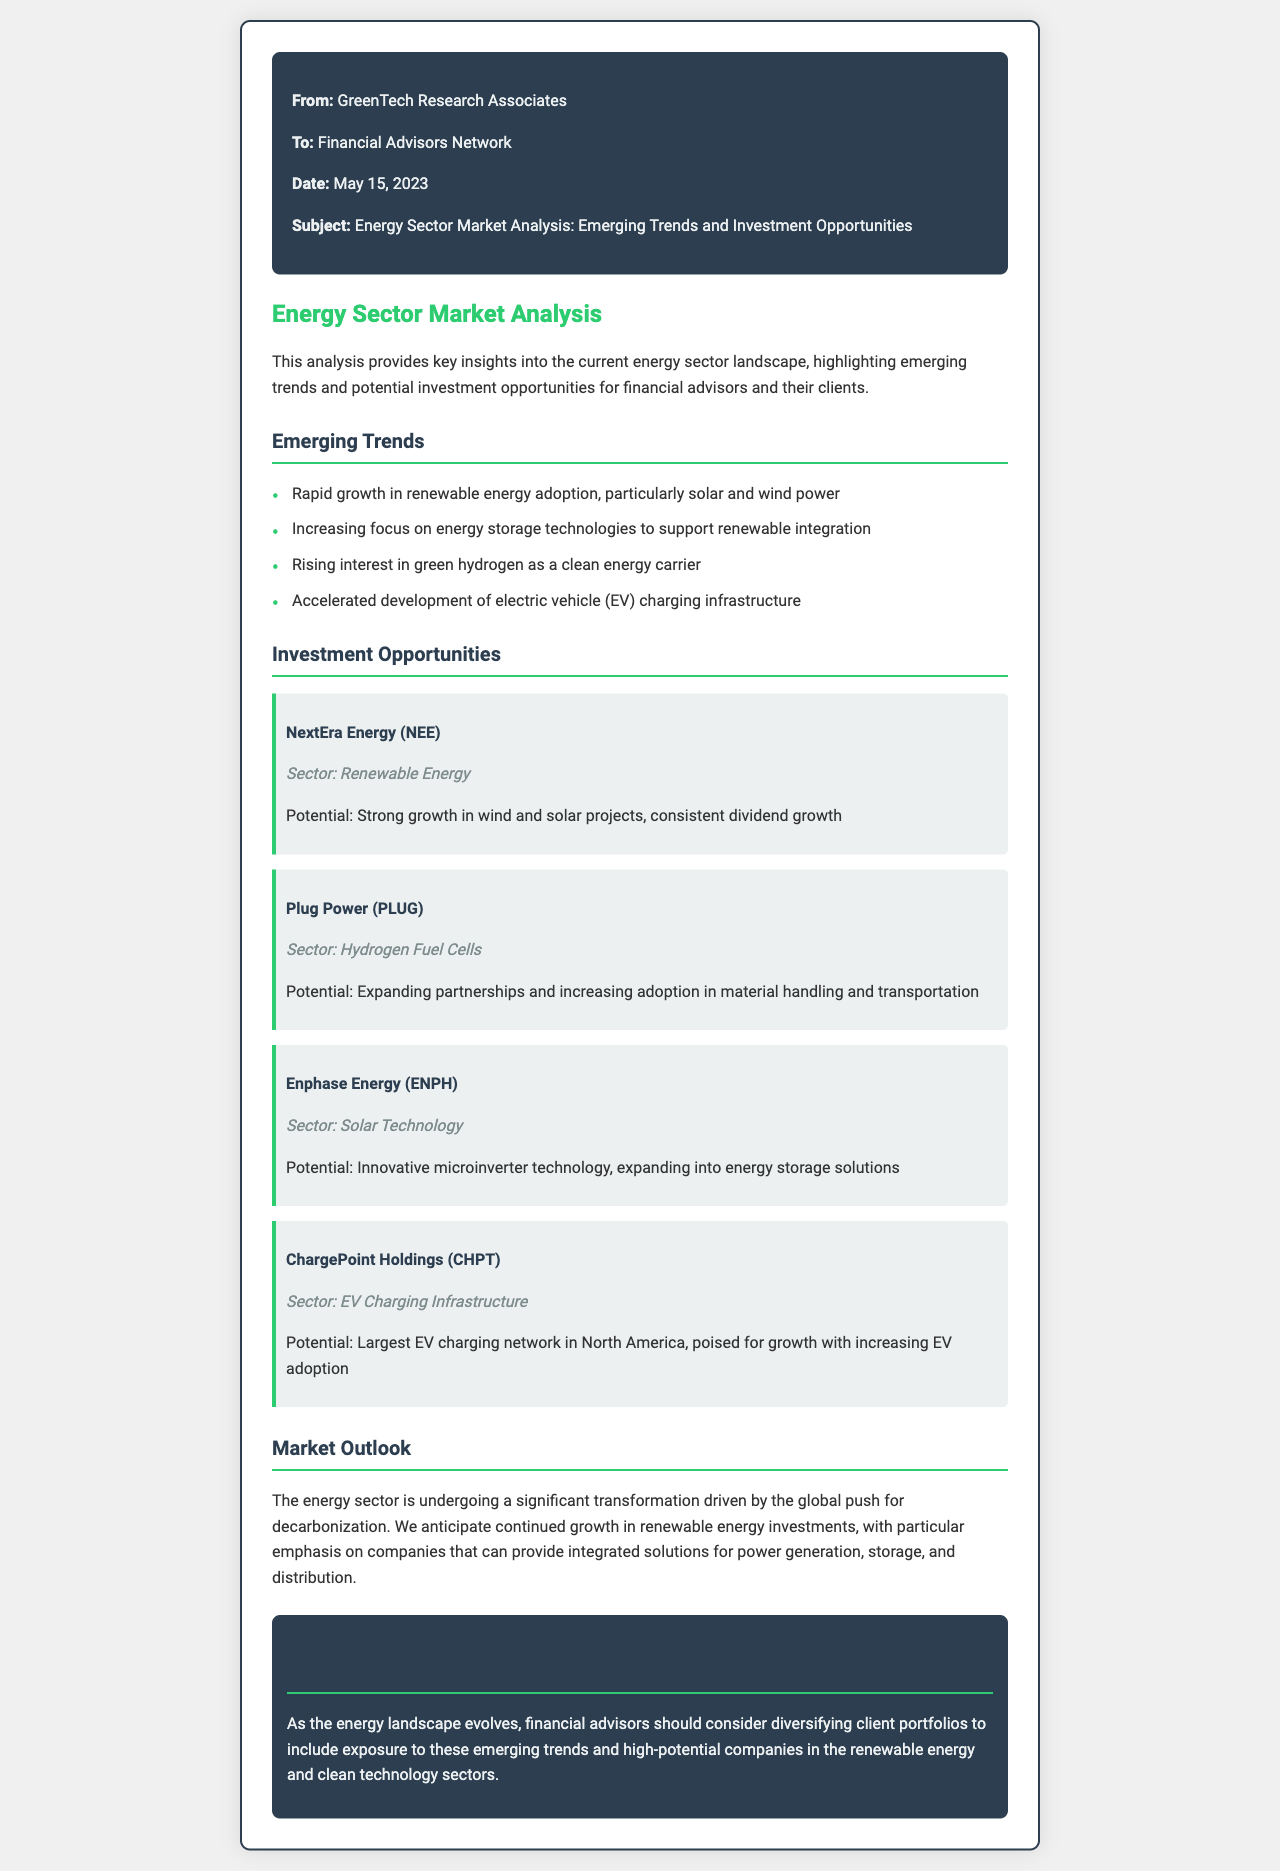What is the date of the fax? The date of the fax is mentioned in the header of the document as May 15, 2023.
Answer: May 15, 2023 Who is the sender of the fax? The sender of the fax is indicated at the top of the document as GreenTech Research Associates.
Answer: GreenTech Research Associates Which company is associated with renewable energy based on the investment opportunities? The company highlighted in the investment opportunities section for renewable energy is NextEra Energy (NEE).
Answer: NextEra Energy (NEE) What type of technology does Enphase Energy specialize in? The document specifies that Enphase Energy specializes in solar technology.
Answer: Solar Technology What is the emerging trend related to energy storage mentioned in the document? The document notes that there is an increasing focus on energy storage technologies to support renewable integration.
Answer: Energy storage technologies What is the primary market outlook for the energy sector according to the document? The document suggests that the energy sector is experiencing significant transformation driven by the global push for decarbonization.
Answer: Decarbonization Which sector is ChargePoint Holdings (CHPT) associated with? ChargePoint Holdings (CHPT) is associated with the EV charging infrastructure sector as stated in the opportunities section.
Answer: EV Charging Infrastructure What does the conclusion recommend for financial advisors? The conclusion recommends diversifying client portfolios to include exposure to emerging trends and high-potential companies in the renewable energy and clean technology sectors.
Answer: Diversifying client portfolios What is the potential of Plug Power (PLUG) as indicated in the document? The document describes Plug Power's potential as expanding partnerships and increasing adoption in material handling and transportation.
Answer: Expanding partnerships and increasing adoption 